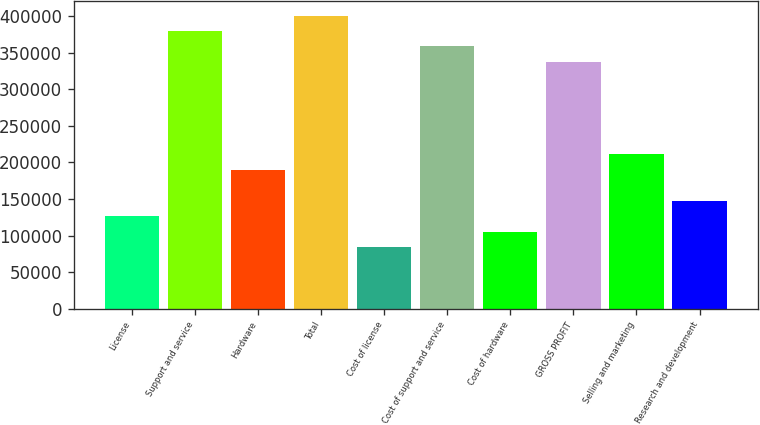<chart> <loc_0><loc_0><loc_500><loc_500><bar_chart><fcel>License<fcel>Support and service<fcel>Hardware<fcel>Total<fcel>Cost of license<fcel>Cost of support and service<fcel>Cost of hardware<fcel>GROSS PROFIT<fcel>Selling and marketing<fcel>Research and development<nl><fcel>126517<fcel>379549<fcel>189775<fcel>400636<fcel>84344.6<fcel>358463<fcel>105431<fcel>337377<fcel>210861<fcel>147603<nl></chart> 